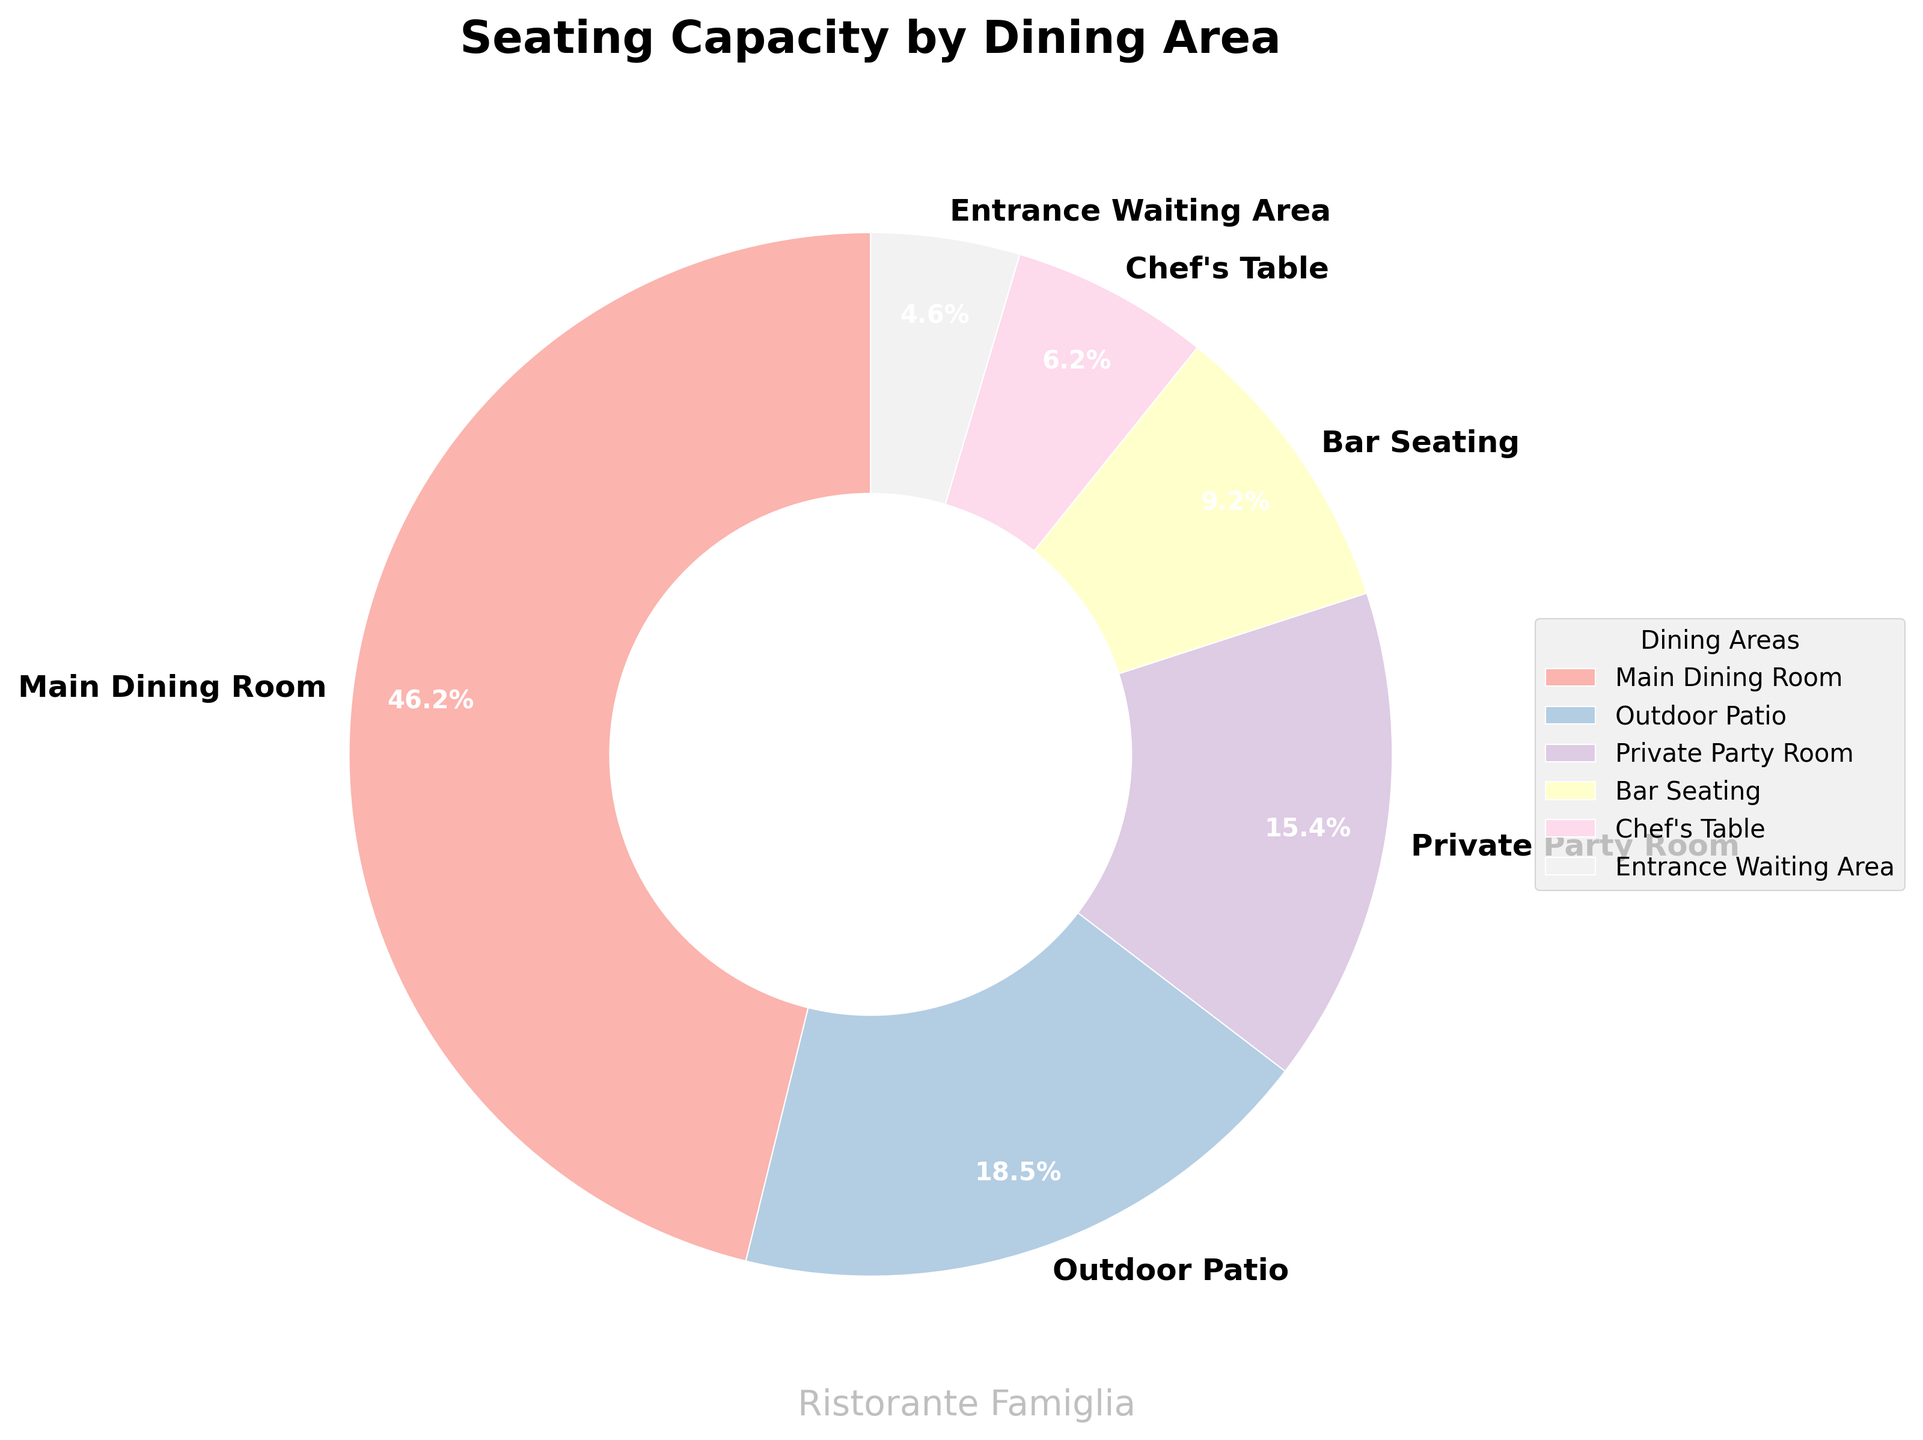Which dining area accounts for the highest seating capacity? The main dining room accounts for the highest seating capacity. By looking at the pie chart, it has the largest wedge with 60 seats.
Answer: Main dining room What percentage of the total seating capacity is found in the outdoor patio and bar seating combined? The outdoor patio has 24 seats and the bar seating has 12 seats. Together, they account for 36 seats. The total seating capacity is 130 seats. The percentage is therefore (36/130) * 100, which is approximately 27.7%.
Answer: 27.7% Which dining area has the smallest seating capacity, and what percentage does it represent? The entrance waiting area has the smallest seating capacity with 6 seats. To find the percentage, we use (6/130) * 100, which is approximately 4.6%.
Answer: Entrance waiting area, 4.6% How does the seating capacity of the chef's table compare to the private party room? The chef's table seats 8 people, while the private party room seats 20 people. Therefore, the private party room has a higher capacity.
Answer: Private party room has higher capacity If we combine the seating capacities of the main dining room, outdoor patio, and bar seating, what is the total, and what percentage of the overall capacity does this represent? The main dining room has 60 seats, the outdoor patio has 24 seats, and the bar seating has 12 seats. Combined, that's 60 + 24 + 12 = 96 seats. The total seating capacity is 130 seats, so the percentage is (96/130) * 100, which is approximately 73.8%.
Answer: 96 seats, 73.8% What is the combined seating capacity for both the entrance waiting area and the chef's table, and how does this compare to the outdoor patio? The entrance waiting area has 6 seats and the chef's table has 8 seats, totaling 14 seats. The outdoor patio has 24 seats. Hence, the outdoor patio can accommodate more people.
Answer: 14 seats, outdoor patio has higher capacity Which two dining areas combined give a seating capacity closest to that of the main dining room? The private party room and the outdoor patio together give 20 + 24 = 44 seats, and the chef's table and the bar seating together give 8 + 12 = 20 seats. The combination of the private party room and the outdoor patio comes the closest to the main dining room's 60 seats.
Answer: Private party room and outdoor patio What is the difference in seating capacity between the outdoor patio and private party room? The outdoor patio has 24 seats, and the private party room has 20 seats. The difference is 24 - 20 = 4 seats.
Answer: 4 seats Which dining area represents approximately 9.2% of the total seating capacity? The chef's table has 8 seats out of a total of 130 seats. Calculating the percentage: (8/130) * 100 ≈ 6.2%. Based on the values given in the pie chart, none of the dining areas exactly match 9.2%.
Answer: None 